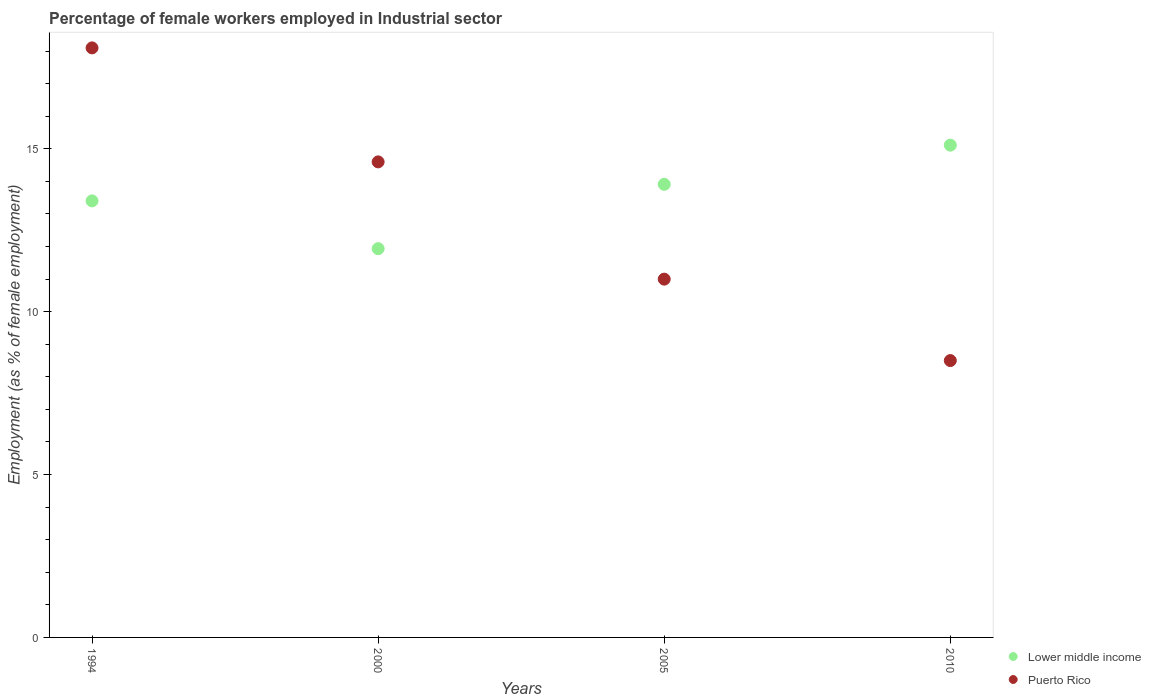How many different coloured dotlines are there?
Keep it short and to the point. 2. What is the percentage of females employed in Industrial sector in Lower middle income in 1994?
Offer a terse response. 13.4. Across all years, what is the maximum percentage of females employed in Industrial sector in Puerto Rico?
Ensure brevity in your answer.  18.1. Across all years, what is the minimum percentage of females employed in Industrial sector in Lower middle income?
Keep it short and to the point. 11.94. In which year was the percentage of females employed in Industrial sector in Lower middle income maximum?
Give a very brief answer. 2010. In which year was the percentage of females employed in Industrial sector in Lower middle income minimum?
Provide a short and direct response. 2000. What is the total percentage of females employed in Industrial sector in Puerto Rico in the graph?
Your response must be concise. 52.2. What is the difference between the percentage of females employed in Industrial sector in Lower middle income in 1994 and that in 2005?
Offer a very short reply. -0.51. What is the difference between the percentage of females employed in Industrial sector in Lower middle income in 2000 and the percentage of females employed in Industrial sector in Puerto Rico in 2010?
Your answer should be very brief. 3.44. What is the average percentage of females employed in Industrial sector in Lower middle income per year?
Make the answer very short. 13.59. In the year 2010, what is the difference between the percentage of females employed in Industrial sector in Lower middle income and percentage of females employed in Industrial sector in Puerto Rico?
Ensure brevity in your answer.  6.61. What is the ratio of the percentage of females employed in Industrial sector in Lower middle income in 2005 to that in 2010?
Provide a succinct answer. 0.92. What is the difference between the highest and the second highest percentage of females employed in Industrial sector in Puerto Rico?
Your response must be concise. 3.5. What is the difference between the highest and the lowest percentage of females employed in Industrial sector in Lower middle income?
Make the answer very short. 3.18. Is the sum of the percentage of females employed in Industrial sector in Puerto Rico in 1994 and 2010 greater than the maximum percentage of females employed in Industrial sector in Lower middle income across all years?
Make the answer very short. Yes. Does the percentage of females employed in Industrial sector in Puerto Rico monotonically increase over the years?
Your answer should be compact. No. How many dotlines are there?
Your answer should be very brief. 2. Are the values on the major ticks of Y-axis written in scientific E-notation?
Make the answer very short. No. Does the graph contain any zero values?
Keep it short and to the point. No. How are the legend labels stacked?
Offer a very short reply. Vertical. What is the title of the graph?
Your answer should be very brief. Percentage of female workers employed in Industrial sector. What is the label or title of the X-axis?
Your answer should be compact. Years. What is the label or title of the Y-axis?
Offer a very short reply. Employment (as % of female employment). What is the Employment (as % of female employment) of Lower middle income in 1994?
Offer a very short reply. 13.4. What is the Employment (as % of female employment) of Puerto Rico in 1994?
Your answer should be very brief. 18.1. What is the Employment (as % of female employment) of Lower middle income in 2000?
Your answer should be compact. 11.94. What is the Employment (as % of female employment) of Puerto Rico in 2000?
Your answer should be compact. 14.6. What is the Employment (as % of female employment) in Lower middle income in 2005?
Your answer should be very brief. 13.91. What is the Employment (as % of female employment) in Lower middle income in 2010?
Your answer should be very brief. 15.11. What is the Employment (as % of female employment) of Puerto Rico in 2010?
Provide a short and direct response. 8.5. Across all years, what is the maximum Employment (as % of female employment) of Lower middle income?
Offer a terse response. 15.11. Across all years, what is the maximum Employment (as % of female employment) in Puerto Rico?
Give a very brief answer. 18.1. Across all years, what is the minimum Employment (as % of female employment) in Lower middle income?
Your response must be concise. 11.94. What is the total Employment (as % of female employment) in Lower middle income in the graph?
Ensure brevity in your answer.  54.36. What is the total Employment (as % of female employment) of Puerto Rico in the graph?
Give a very brief answer. 52.2. What is the difference between the Employment (as % of female employment) of Lower middle income in 1994 and that in 2000?
Provide a succinct answer. 1.47. What is the difference between the Employment (as % of female employment) of Puerto Rico in 1994 and that in 2000?
Ensure brevity in your answer.  3.5. What is the difference between the Employment (as % of female employment) of Lower middle income in 1994 and that in 2005?
Offer a very short reply. -0.51. What is the difference between the Employment (as % of female employment) of Lower middle income in 1994 and that in 2010?
Ensure brevity in your answer.  -1.71. What is the difference between the Employment (as % of female employment) in Lower middle income in 2000 and that in 2005?
Your answer should be very brief. -1.97. What is the difference between the Employment (as % of female employment) in Lower middle income in 2000 and that in 2010?
Keep it short and to the point. -3.18. What is the difference between the Employment (as % of female employment) of Lower middle income in 2005 and that in 2010?
Ensure brevity in your answer.  -1.2. What is the difference between the Employment (as % of female employment) in Lower middle income in 1994 and the Employment (as % of female employment) in Puerto Rico in 2000?
Provide a succinct answer. -1.2. What is the difference between the Employment (as % of female employment) of Lower middle income in 1994 and the Employment (as % of female employment) of Puerto Rico in 2005?
Give a very brief answer. 2.4. What is the difference between the Employment (as % of female employment) of Lower middle income in 1994 and the Employment (as % of female employment) of Puerto Rico in 2010?
Keep it short and to the point. 4.9. What is the difference between the Employment (as % of female employment) of Lower middle income in 2000 and the Employment (as % of female employment) of Puerto Rico in 2005?
Your response must be concise. 0.94. What is the difference between the Employment (as % of female employment) of Lower middle income in 2000 and the Employment (as % of female employment) of Puerto Rico in 2010?
Provide a succinct answer. 3.44. What is the difference between the Employment (as % of female employment) in Lower middle income in 2005 and the Employment (as % of female employment) in Puerto Rico in 2010?
Your response must be concise. 5.41. What is the average Employment (as % of female employment) of Lower middle income per year?
Offer a very short reply. 13.59. What is the average Employment (as % of female employment) in Puerto Rico per year?
Offer a very short reply. 13.05. In the year 1994, what is the difference between the Employment (as % of female employment) of Lower middle income and Employment (as % of female employment) of Puerto Rico?
Offer a very short reply. -4.7. In the year 2000, what is the difference between the Employment (as % of female employment) of Lower middle income and Employment (as % of female employment) of Puerto Rico?
Provide a succinct answer. -2.66. In the year 2005, what is the difference between the Employment (as % of female employment) in Lower middle income and Employment (as % of female employment) in Puerto Rico?
Offer a very short reply. 2.91. In the year 2010, what is the difference between the Employment (as % of female employment) of Lower middle income and Employment (as % of female employment) of Puerto Rico?
Offer a terse response. 6.61. What is the ratio of the Employment (as % of female employment) of Lower middle income in 1994 to that in 2000?
Keep it short and to the point. 1.12. What is the ratio of the Employment (as % of female employment) in Puerto Rico in 1994 to that in 2000?
Offer a very short reply. 1.24. What is the ratio of the Employment (as % of female employment) of Lower middle income in 1994 to that in 2005?
Keep it short and to the point. 0.96. What is the ratio of the Employment (as % of female employment) of Puerto Rico in 1994 to that in 2005?
Your answer should be very brief. 1.65. What is the ratio of the Employment (as % of female employment) of Lower middle income in 1994 to that in 2010?
Offer a very short reply. 0.89. What is the ratio of the Employment (as % of female employment) in Puerto Rico in 1994 to that in 2010?
Offer a very short reply. 2.13. What is the ratio of the Employment (as % of female employment) in Lower middle income in 2000 to that in 2005?
Make the answer very short. 0.86. What is the ratio of the Employment (as % of female employment) in Puerto Rico in 2000 to that in 2005?
Your response must be concise. 1.33. What is the ratio of the Employment (as % of female employment) in Lower middle income in 2000 to that in 2010?
Provide a succinct answer. 0.79. What is the ratio of the Employment (as % of female employment) of Puerto Rico in 2000 to that in 2010?
Ensure brevity in your answer.  1.72. What is the ratio of the Employment (as % of female employment) of Lower middle income in 2005 to that in 2010?
Your answer should be very brief. 0.92. What is the ratio of the Employment (as % of female employment) of Puerto Rico in 2005 to that in 2010?
Give a very brief answer. 1.29. What is the difference between the highest and the second highest Employment (as % of female employment) in Lower middle income?
Ensure brevity in your answer.  1.2. What is the difference between the highest and the second highest Employment (as % of female employment) in Puerto Rico?
Your answer should be very brief. 3.5. What is the difference between the highest and the lowest Employment (as % of female employment) in Lower middle income?
Your answer should be very brief. 3.18. What is the difference between the highest and the lowest Employment (as % of female employment) in Puerto Rico?
Give a very brief answer. 9.6. 